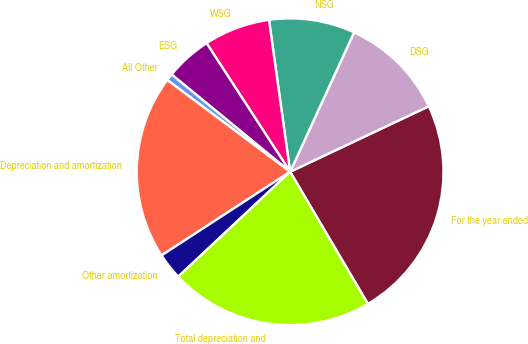<chart> <loc_0><loc_0><loc_500><loc_500><pie_chart><fcel>For the year ended<fcel>DSG<fcel>NSG<fcel>WSG<fcel>ESG<fcel>All Other<fcel>Depreciation and amortization<fcel>Other amortization<fcel>Total depreciation and<nl><fcel>23.56%<fcel>11.13%<fcel>9.05%<fcel>6.97%<fcel>4.89%<fcel>0.73%<fcel>19.39%<fcel>2.81%<fcel>21.48%<nl></chart> 